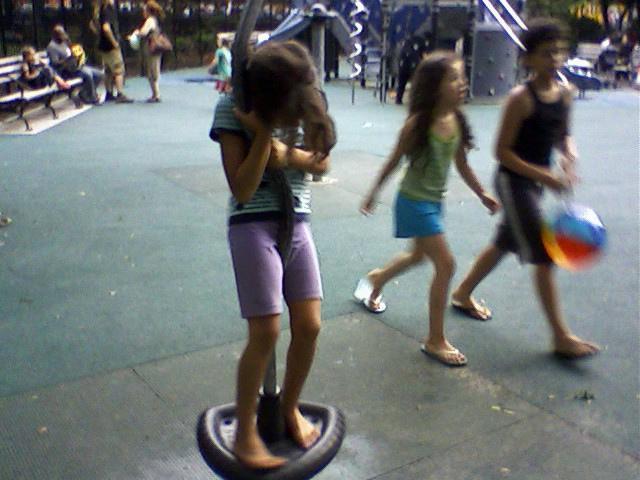How many people can be seen?
Give a very brief answer. 3. 